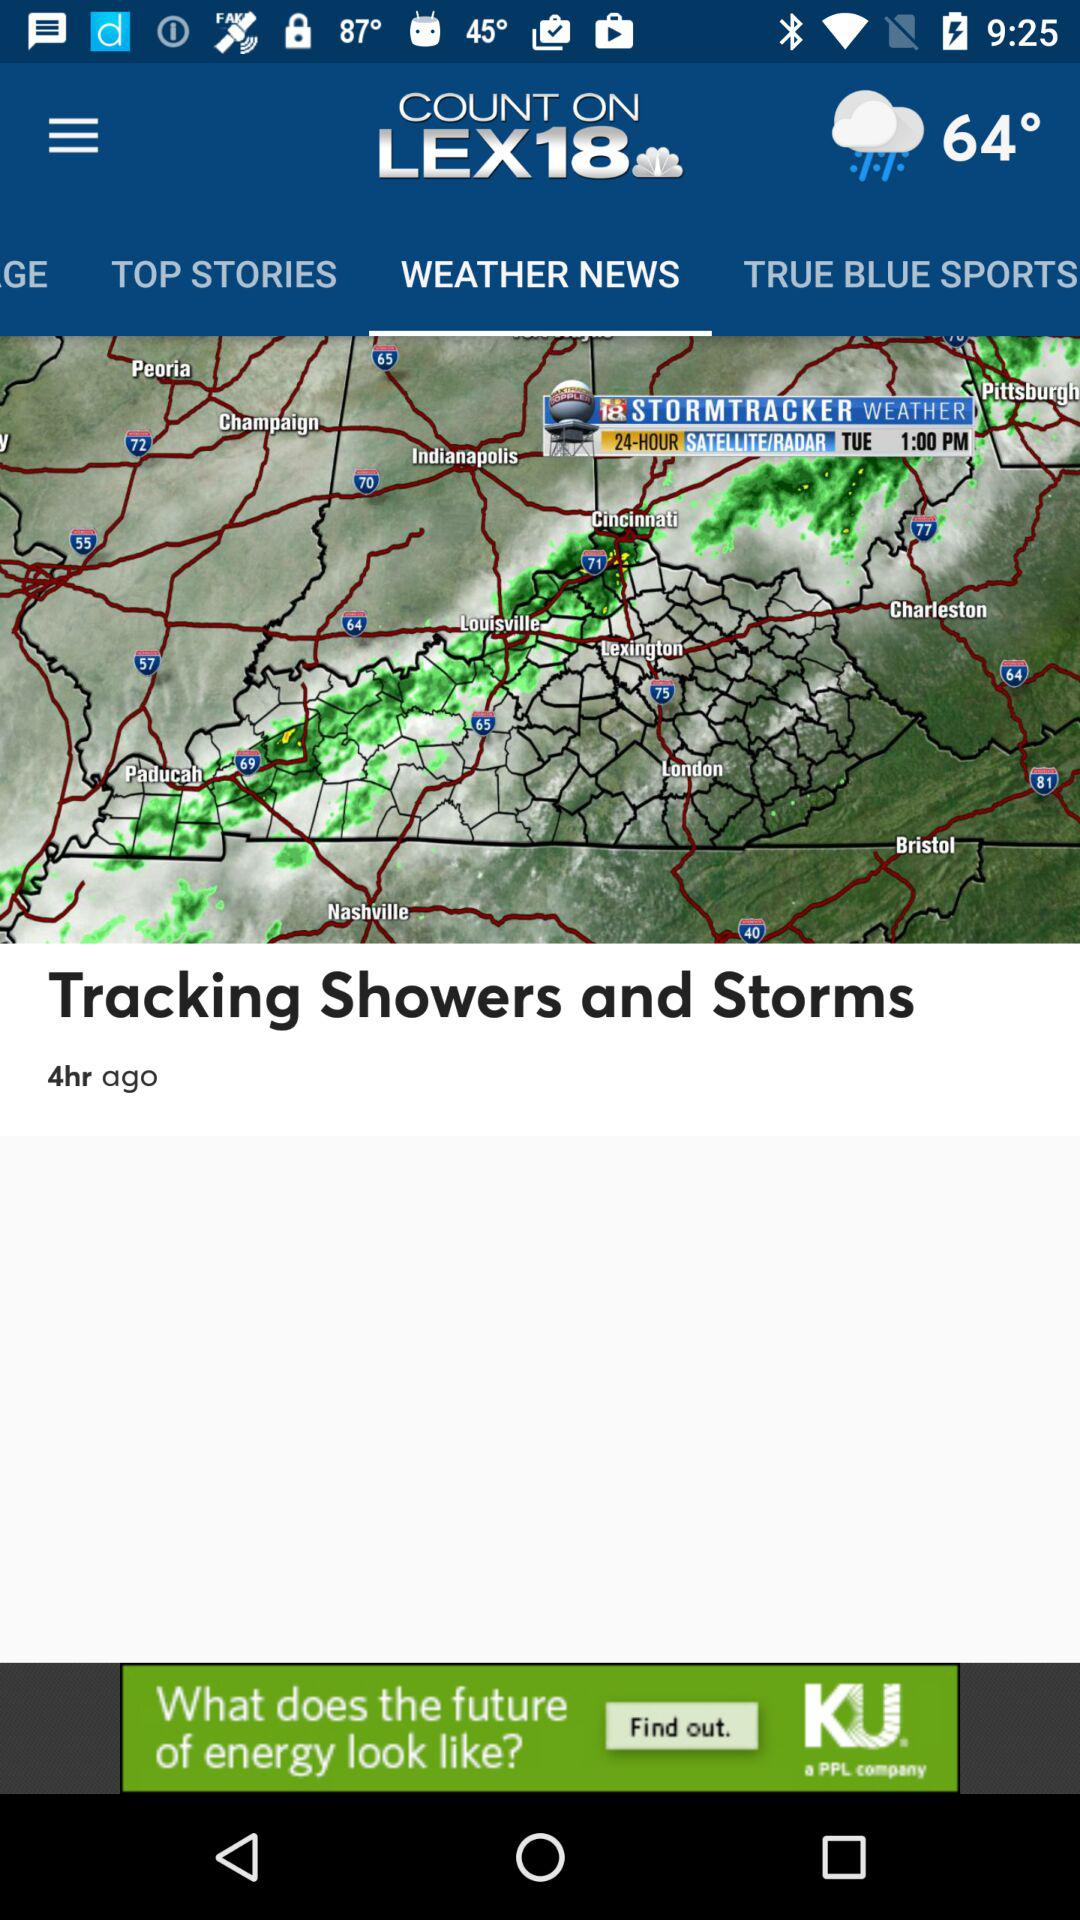How many hours ago was "Tracking Showers and Storms" updated? It was updated 4 hours ago. 